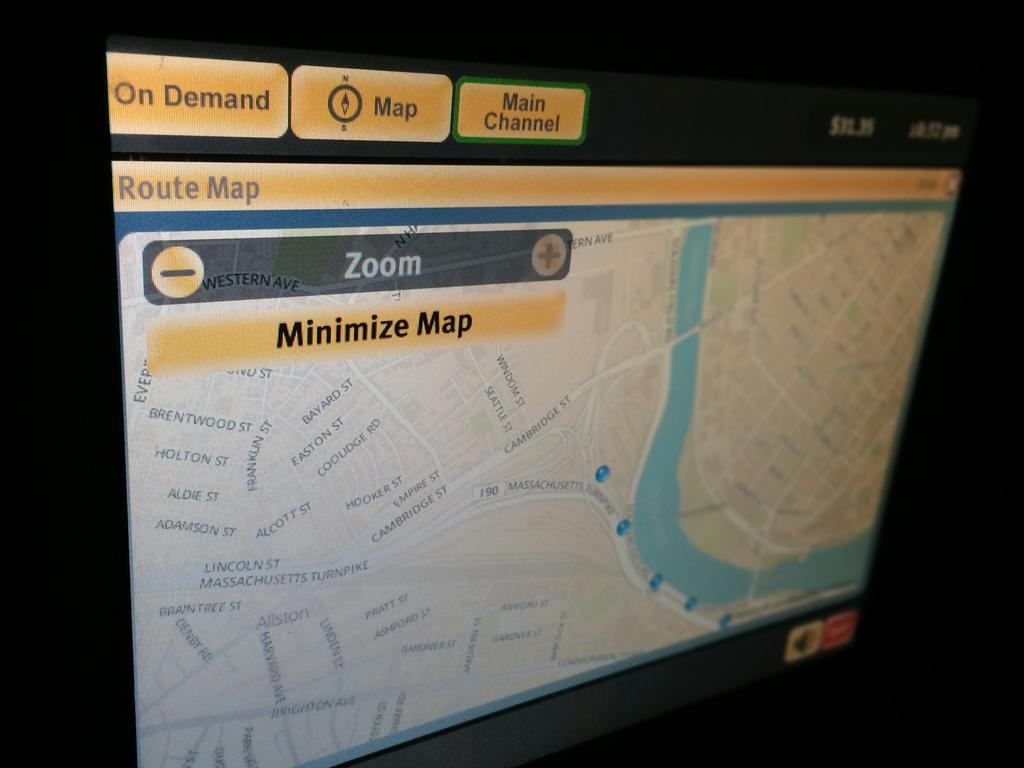<image>
Summarize the visual content of the image. A route map that lets you zoom in and minimize the map 